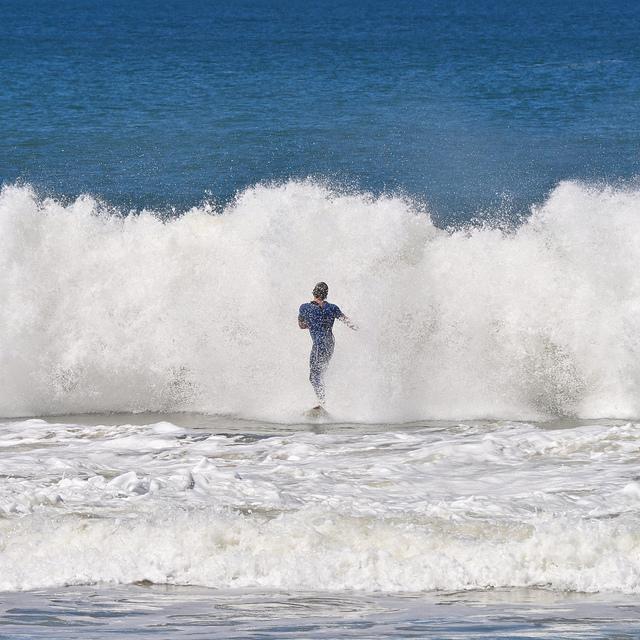Where is the surfer in the picture?
Answer briefly. In water. What is in the background?
Concise answer only. Water. What is the person doing?
Write a very short answer. Surfing. 